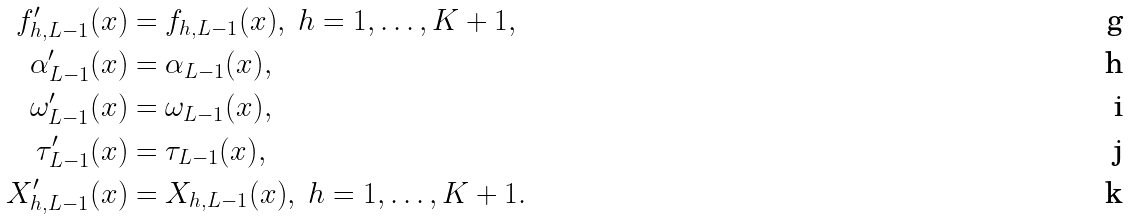Convert formula to latex. <formula><loc_0><loc_0><loc_500><loc_500>f ^ { \prime } _ { h , L - 1 } ( x ) & = f _ { h , L - 1 } ( x ) , \ h = 1 , \dots , K + 1 , \\ \alpha ^ { \prime } _ { L - 1 } ( x ) & = \alpha _ { L - 1 } ( x ) , \\ \omega _ { L - 1 } ^ { \prime } ( x ) & = \omega _ { L - 1 } ( x ) , \\ \tau _ { L - 1 } ^ { \prime } ( x ) & = \tau _ { L - 1 } ( x ) , \\ X _ { h , L - 1 } ^ { \prime } ( x ) & = X _ { h , L - 1 } ( x ) , \ h = 1 , \dots , K + 1 .</formula> 